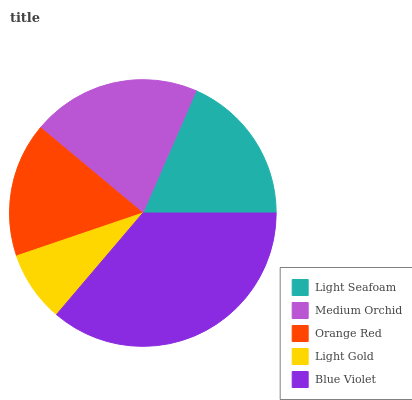Is Light Gold the minimum?
Answer yes or no. Yes. Is Blue Violet the maximum?
Answer yes or no. Yes. Is Medium Orchid the minimum?
Answer yes or no. No. Is Medium Orchid the maximum?
Answer yes or no. No. Is Medium Orchid greater than Light Seafoam?
Answer yes or no. Yes. Is Light Seafoam less than Medium Orchid?
Answer yes or no. Yes. Is Light Seafoam greater than Medium Orchid?
Answer yes or no. No. Is Medium Orchid less than Light Seafoam?
Answer yes or no. No. Is Light Seafoam the high median?
Answer yes or no. Yes. Is Light Seafoam the low median?
Answer yes or no. Yes. Is Blue Violet the high median?
Answer yes or no. No. Is Blue Violet the low median?
Answer yes or no. No. 